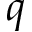<formula> <loc_0><loc_0><loc_500><loc_500>q</formula> 